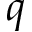<formula> <loc_0><loc_0><loc_500><loc_500>q</formula> 